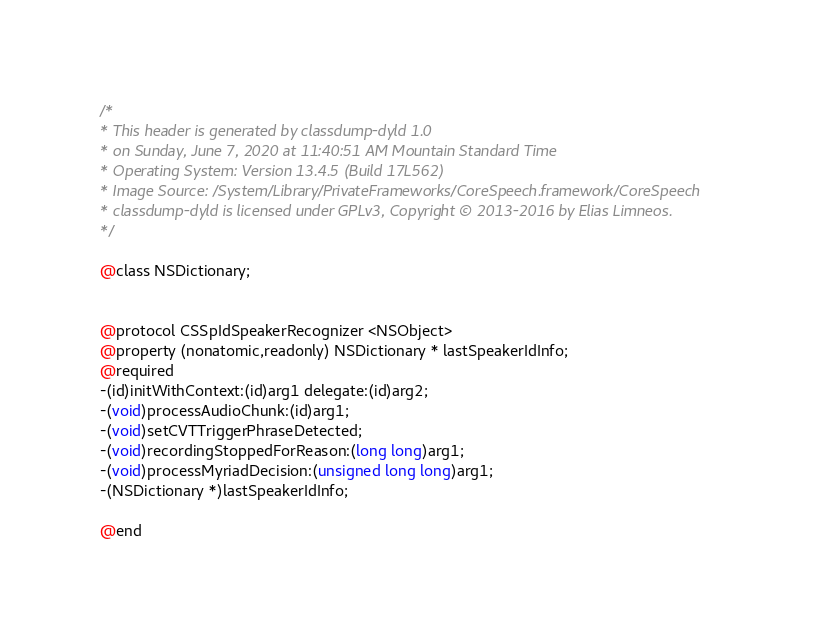Convert code to text. <code><loc_0><loc_0><loc_500><loc_500><_C_>/*
* This header is generated by classdump-dyld 1.0
* on Sunday, June 7, 2020 at 11:40:51 AM Mountain Standard Time
* Operating System: Version 13.4.5 (Build 17L562)
* Image Source: /System/Library/PrivateFrameworks/CoreSpeech.framework/CoreSpeech
* classdump-dyld is licensed under GPLv3, Copyright © 2013-2016 by Elias Limneos.
*/

@class NSDictionary;


@protocol CSSpIdSpeakerRecognizer <NSObject>
@property (nonatomic,readonly) NSDictionary * lastSpeakerIdInfo; 
@required
-(id)initWithContext:(id)arg1 delegate:(id)arg2;
-(void)processAudioChunk:(id)arg1;
-(void)setCVTTriggerPhraseDetected;
-(void)recordingStoppedForReason:(long long)arg1;
-(void)processMyriadDecision:(unsigned long long)arg1;
-(NSDictionary *)lastSpeakerIdInfo;

@end

</code> 